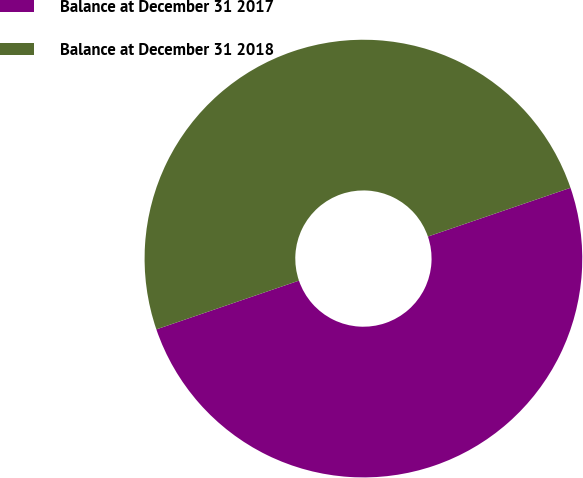<chart> <loc_0><loc_0><loc_500><loc_500><pie_chart><fcel>Balance at December 31 2017<fcel>Balance at December 31 2018<nl><fcel>50.0%<fcel>50.0%<nl></chart> 